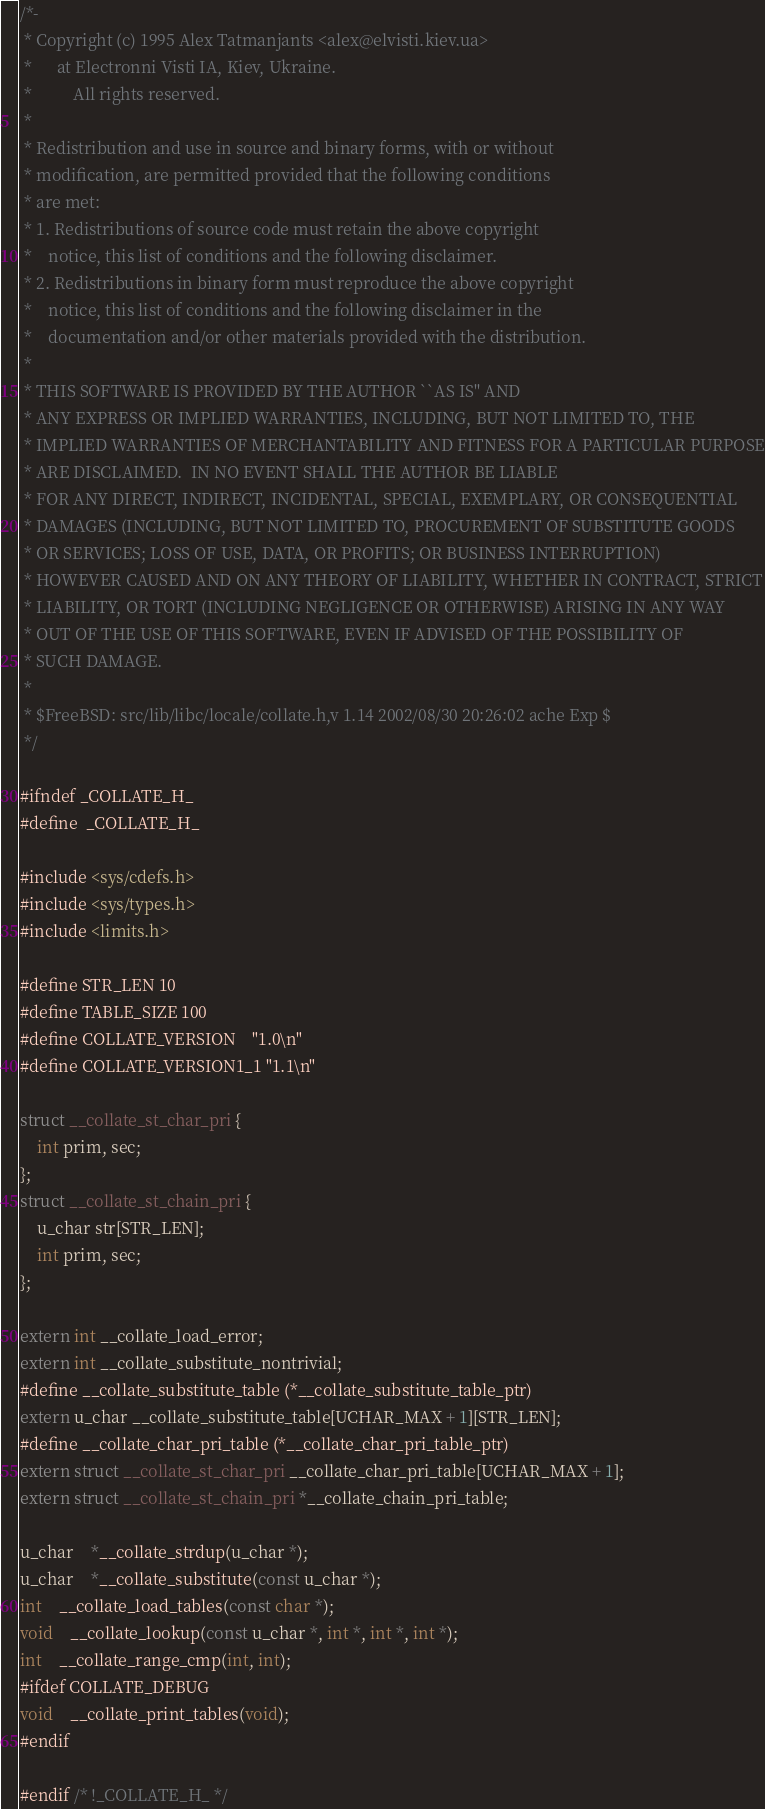Convert code to text. <code><loc_0><loc_0><loc_500><loc_500><_C_>/*-
 * Copyright (c) 1995 Alex Tatmanjants <alex@elvisti.kiev.ua>
 *		at Electronni Visti IA, Kiev, Ukraine.
 *			All rights reserved.
 *
 * Redistribution and use in source and binary forms, with or without
 * modification, are permitted provided that the following conditions
 * are met:
 * 1. Redistributions of source code must retain the above copyright
 *    notice, this list of conditions and the following disclaimer.
 * 2. Redistributions in binary form must reproduce the above copyright
 *    notice, this list of conditions and the following disclaimer in the
 *    documentation and/or other materials provided with the distribution.
 *
 * THIS SOFTWARE IS PROVIDED BY THE AUTHOR ``AS IS'' AND
 * ANY EXPRESS OR IMPLIED WARRANTIES, INCLUDING, BUT NOT LIMITED TO, THE
 * IMPLIED WARRANTIES OF MERCHANTABILITY AND FITNESS FOR A PARTICULAR PURPOSE
 * ARE DISCLAIMED.  IN NO EVENT SHALL THE AUTHOR BE LIABLE
 * FOR ANY DIRECT, INDIRECT, INCIDENTAL, SPECIAL, EXEMPLARY, OR CONSEQUENTIAL
 * DAMAGES (INCLUDING, BUT NOT LIMITED TO, PROCUREMENT OF SUBSTITUTE GOODS
 * OR SERVICES; LOSS OF USE, DATA, OR PROFITS; OR BUSINESS INTERRUPTION)
 * HOWEVER CAUSED AND ON ANY THEORY OF LIABILITY, WHETHER IN CONTRACT, STRICT
 * LIABILITY, OR TORT (INCLUDING NEGLIGENCE OR OTHERWISE) ARISING IN ANY WAY
 * OUT OF THE USE OF THIS SOFTWARE, EVEN IF ADVISED OF THE POSSIBILITY OF
 * SUCH DAMAGE.
 *
 * $FreeBSD: src/lib/libc/locale/collate.h,v 1.14 2002/08/30 20:26:02 ache Exp $
 */

#ifndef _COLLATE_H_
#define	_COLLATE_H_

#include <sys/cdefs.h>
#include <sys/types.h>
#include <limits.h>

#define STR_LEN 10
#define TABLE_SIZE 100
#define COLLATE_VERSION    "1.0\n"
#define COLLATE_VERSION1_1 "1.1\n"

struct __collate_st_char_pri {
	int prim, sec;
};
struct __collate_st_chain_pri {
	u_char str[STR_LEN];
	int prim, sec;
};

extern int __collate_load_error;
extern int __collate_substitute_nontrivial;
#define __collate_substitute_table (*__collate_substitute_table_ptr)
extern u_char __collate_substitute_table[UCHAR_MAX + 1][STR_LEN];
#define __collate_char_pri_table (*__collate_char_pri_table_ptr)
extern struct __collate_st_char_pri __collate_char_pri_table[UCHAR_MAX + 1];
extern struct __collate_st_chain_pri *__collate_chain_pri_table;

u_char	*__collate_strdup(u_char *);
u_char	*__collate_substitute(const u_char *);
int	__collate_load_tables(const char *);
void	__collate_lookup(const u_char *, int *, int *, int *);
int	__collate_range_cmp(int, int);
#ifdef COLLATE_DEBUG
void	__collate_print_tables(void);
#endif

#endif /* !_COLLATE_H_ */
</code> 